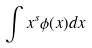Convert formula to latex. <formula><loc_0><loc_0><loc_500><loc_500>\int x ^ { s } \phi ( x ) d x</formula> 